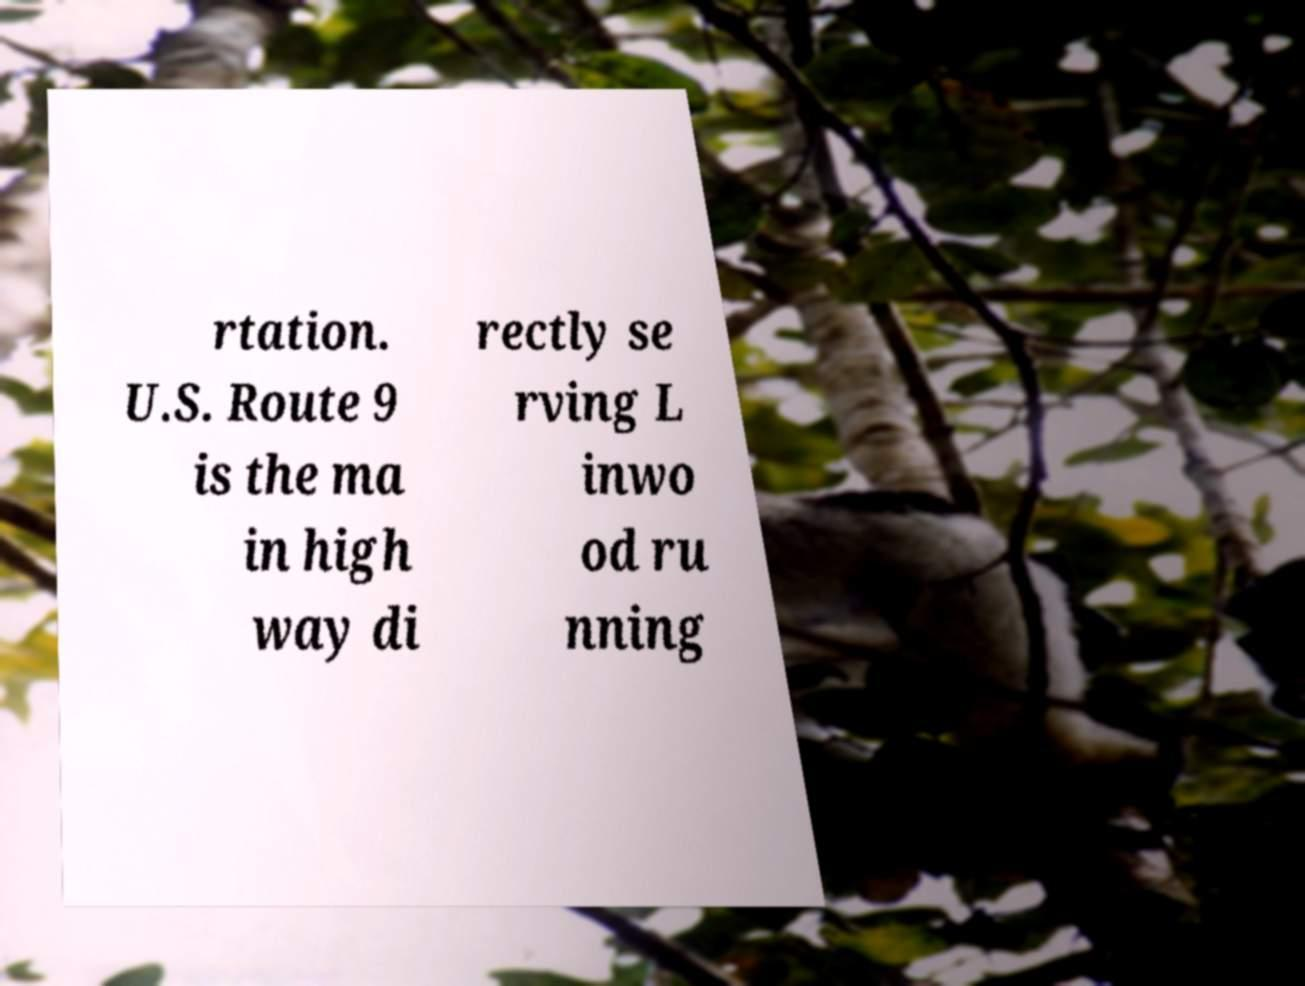For documentation purposes, I need the text within this image transcribed. Could you provide that? rtation. U.S. Route 9 is the ma in high way di rectly se rving L inwo od ru nning 